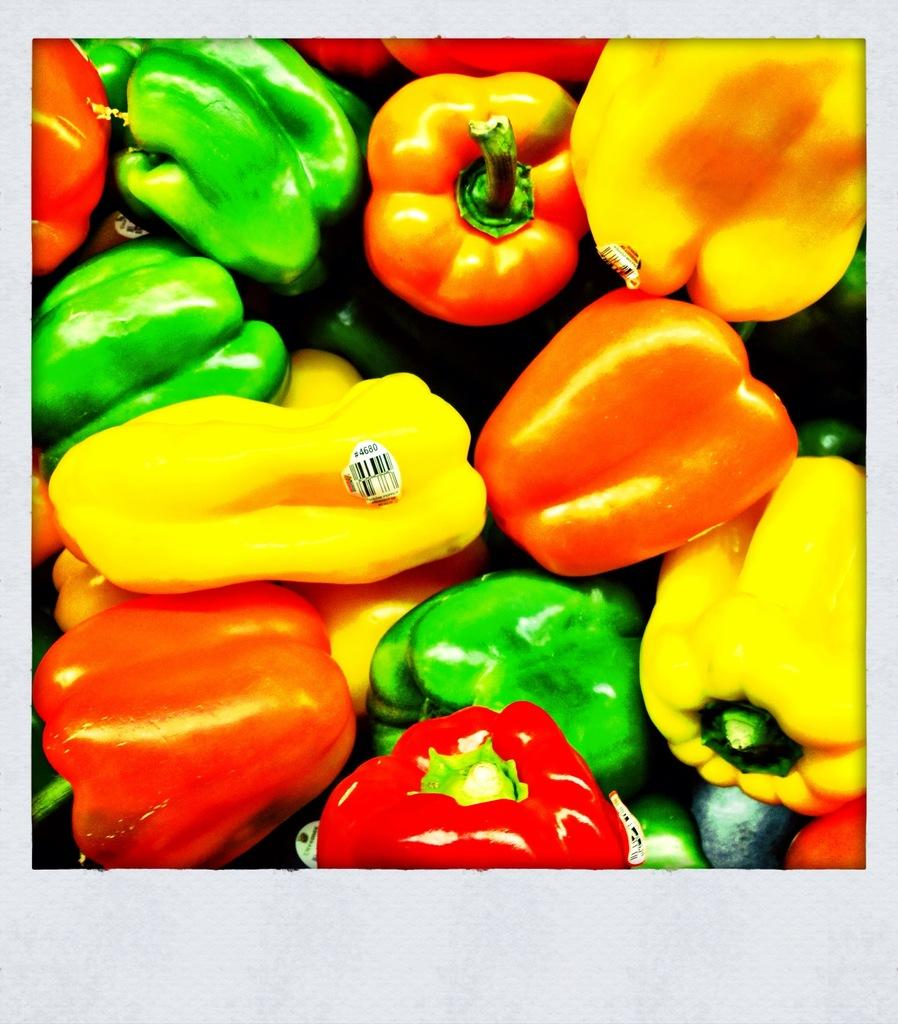What type of vegetables are present in the image? There are capsicums of different colors in the image. Can you describe any specific features of the capsicums? One of the capsicums has a label attached to it. What type of bait is being used to catch the ghost in the image? There is no bait or ghost present in the image; it features capsicums of different colors. 